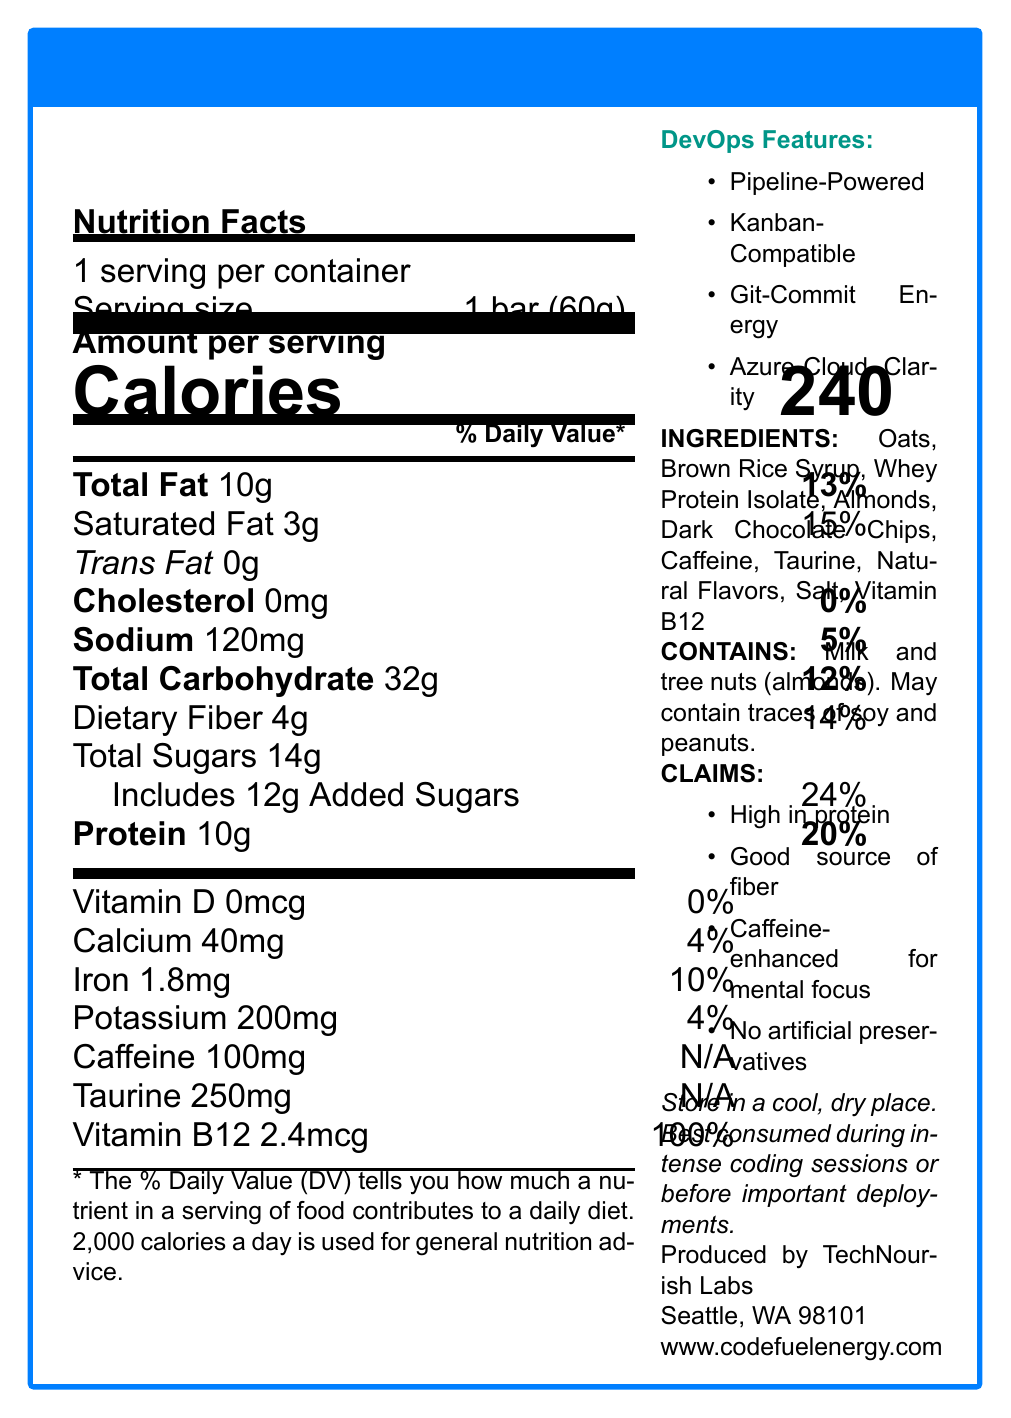what is the serving size of the CodeFuel Energy Bar? The document states that the serving size of the CodeFuel Energy Bar is 1 bar (60g).
Answer: 1 bar (60g) how many calories are in a single serving of the CodeFuel Energy Bar? According to the document, each serving of the CodeFuel Energy Bar contains 240 calories.
Answer: 240 calories how much dietary fiber is in the CodeFuel Energy Bar, and what percentage of the daily value does it represent? The document lists that the CodeFuel Energy Bar has 4g of dietary fiber, which is 14% of the daily value.
Answer: 4g, 14% what is the amount of caffeine in the CodeFuel Energy Bar? The document specifies that the CodeFuel Energy Bar contains 100mg of caffeine.
Answer: 100mg which vitamin in the CodeFuel Energy Bar provides 100% of the daily value? The document indicates that Vitamin B12 in the CodeFuel Energy Bar provides 100% of the daily value.
Answer: Vitamin B12 what allergens are present in the CodeFuel Energy Bar? The allergen information in the document reveals that the bar contains milk and tree nuts (almonds) and may contain traces of soy and peanuts.
Answer: Milk and tree nuts (almonds) what are the first three ingredients listed for the CodeFuel Energy Bar? The ingredients section lists Oats, Brown Rice Syrup, and Whey Protein Isolate as the first three ingredients.
Answer: Oats, Brown Rice Syrup, Whey Protein Isolate what is the amount of added sugars in the CodeFuel Energy Bar, and what percentage of the daily value does it represent? According to the document, the bar includes 12g of added sugars, which is 24% of the daily value.
Answer: 12g, 24% which of these features is not listed as an AzureDevOps-inspired feature of the CodeFuel Energy Bar? A. Pipeline-Powered B. CI/CD Enhancer C. Git-Commit Energy D. Azure-Cloud Clarity The document lists Pipeline-Powered, Kanban-Compatible, Git-Commit Energy, and Azure-Cloud Clarity, but not CI/CD Enhancer.
Answer: B. CI/CD Enhancer what is the sodium content in the CodeFuel Energy Bar, and what percentage of the daily value does it represent? The document notes that the bar contains 120mg of sodium, constituting 5% of the daily value.
Answer: 120mg, 5% what should be the storage condition for the CodeFuel Energy Bar? A. Refrigerated B. Room temperature C. Frozen D. In a cool, dry place The storage instructions in the document specify that the bar should be stored in a cool, dry place.
Answer: D. In a cool, dry place does the CodeFuel Energy Bar contain any artificial preservatives? The document claims that the CodeFuel Energy Bar contains no artificial preservatives.
Answer: No is the amount of iron provided by the CodeFuel Energy Bar higher than 5% of the daily value? The document states that the CodeFuel Energy Bar includes 1.8mg of iron, which is 10% of the daily value, higher than 5%.
Answer: Yes summarize the main features and nutritional insights of the CodeFuel Energy Bar. The CodeFuel Energy Bar is marketed towards IT professionals, emphasizing its caffeine content and AzureDevOps-inspired features for mental focus and productivity during work sessions. Its nutritional profile includes key elements like protein, fiber, and energy-boosting compounds.
Answer: The CodeFuel Energy Bar is a caffeine-enhanced snack designed for IT professionals, particularly DevOps engineers. It offers 240 calories per bar, with 10g of protein and 4g of dietary fiber. The bar contains 100mg of caffeine and 250mg of taurine for mental focus. It is high in protein, a good source of fiber, and has no artificial preservatives. It also offers AzureDevOps-inspired features like Pipeline-Powered and Git-Commit Energy. who is the manufacturer of the CodeFuel Energy Bar? The document states that the CodeFuel Energy Bar is produced by TechNourish Labs, located in Seattle, WA.
Answer: TechNourish Labs how much vitamin D is present in the CodeFuel Energy Bar? According to the document, the CodeFuel Energy Bar contains 0mcg of vitamin D.
Answer: 0mcg what certifications does the CodeFuel Energy Bar have for being organic or non-GMO? The document does not provide any information regarding organic or non-GMO certifications for the CodeFuel Energy Bar.
Answer: Cannot be determined 